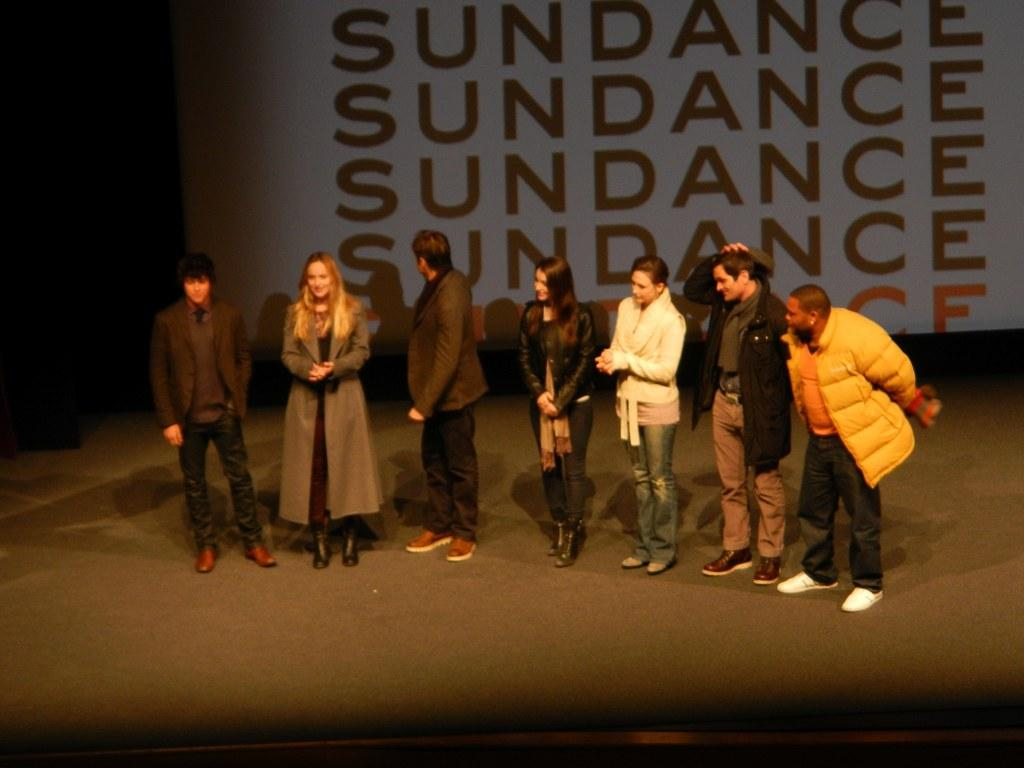What are the people in the image doing? The persons are standing on a dais in the image. What can be seen in the background of the image? There is a screen and a wall in the background of the image. What type of house is visible in the image? There is no house present in the image; it features a screen and a wall in the background. How many family members can be seen in the image? There is no information about family members in the image, as it only shows persons standing on a dais with a screen and a wall in the background. 